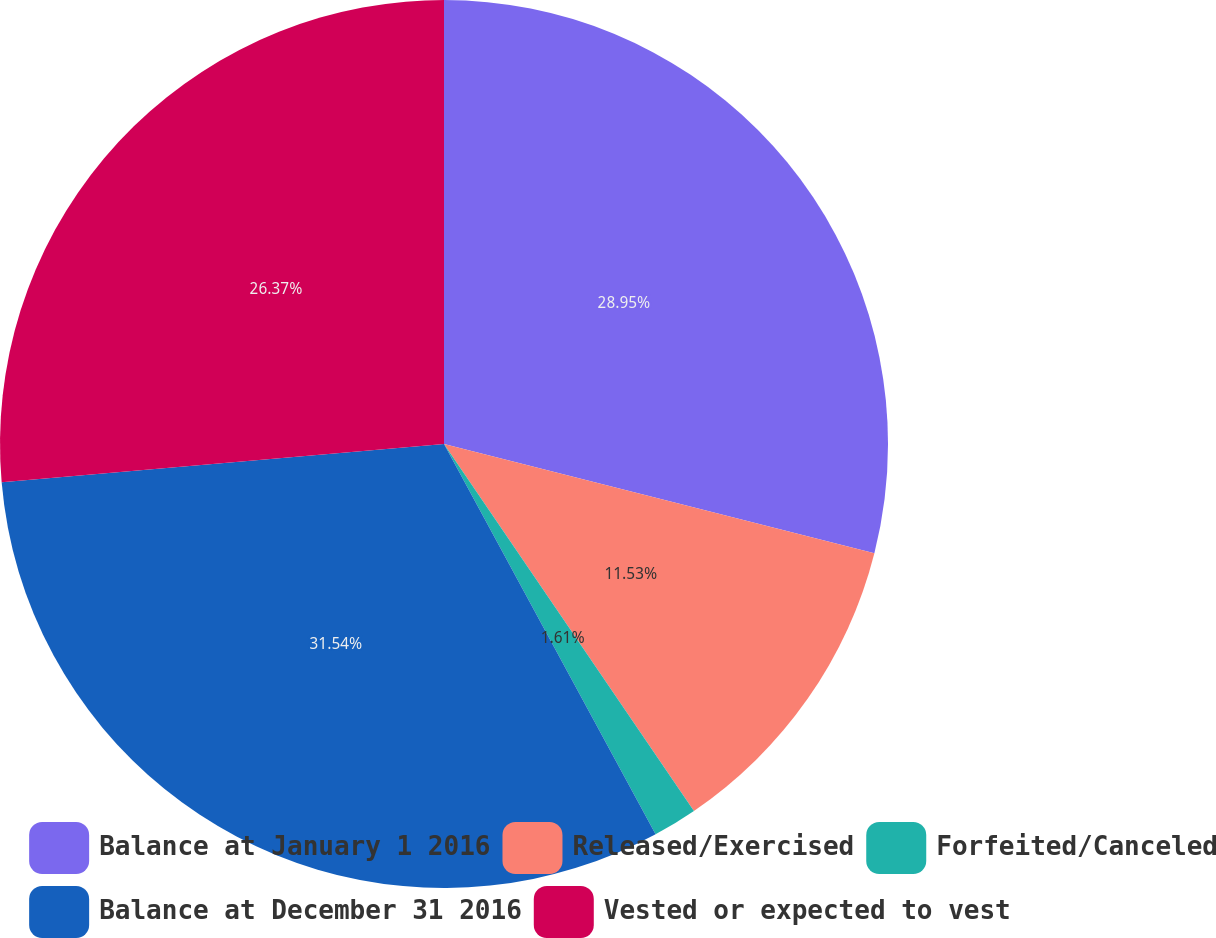Convert chart. <chart><loc_0><loc_0><loc_500><loc_500><pie_chart><fcel>Balance at January 1 2016<fcel>Released/Exercised<fcel>Forfeited/Canceled<fcel>Balance at December 31 2016<fcel>Vested or expected to vest<nl><fcel>28.95%<fcel>11.53%<fcel>1.61%<fcel>31.53%<fcel>26.37%<nl></chart> 